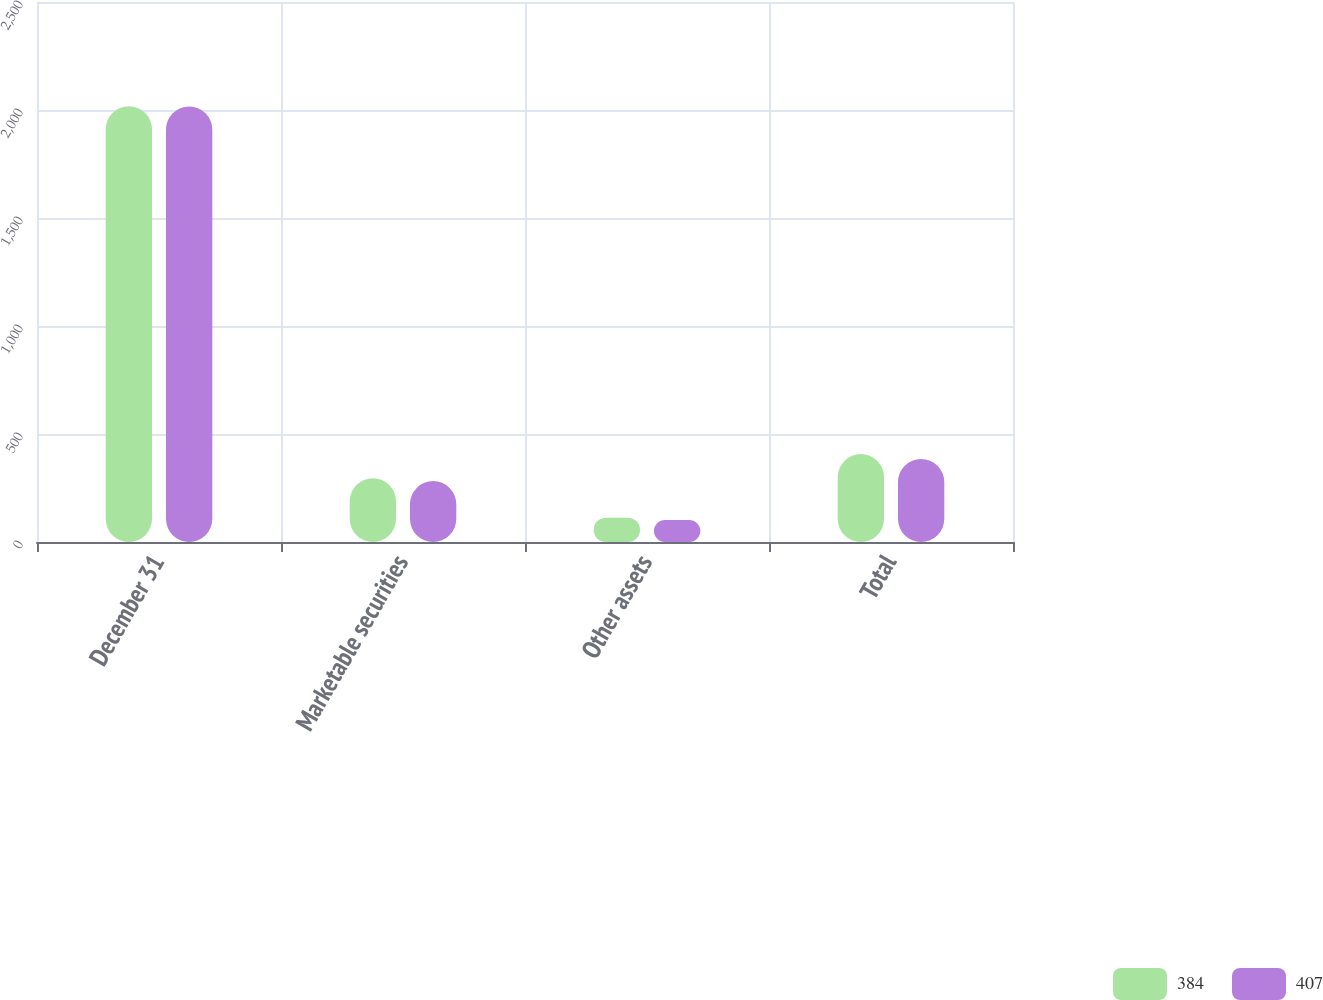Convert chart. <chart><loc_0><loc_0><loc_500><loc_500><stacked_bar_chart><ecel><fcel>December 31<fcel>Marketable securities<fcel>Other assets<fcel>Total<nl><fcel>384<fcel>2017<fcel>295<fcel>112<fcel>407<nl><fcel>407<fcel>2016<fcel>282<fcel>102<fcel>384<nl></chart> 